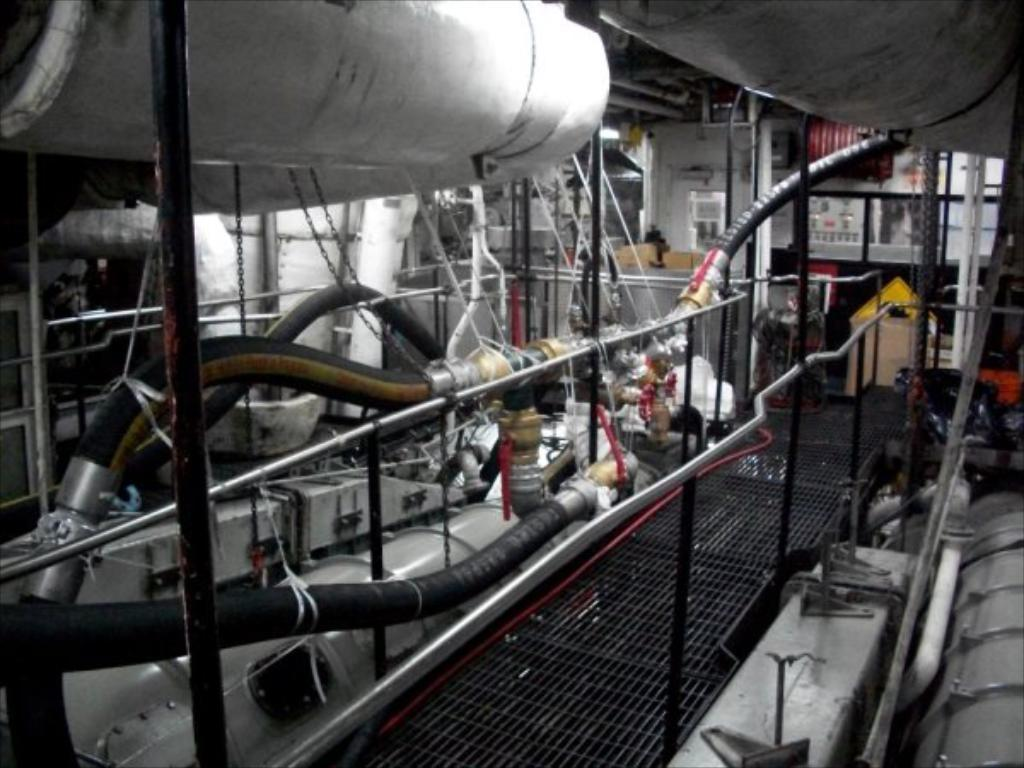What color are the pipes in the image? The pipes in the image are black. What can be seen in the image besides the pipes? There is a fence and other machines in the image. How many springs can be seen attached to the pipes in the image? There are no springs present in the image; it only features black color pipes, a fence, and other machines. 